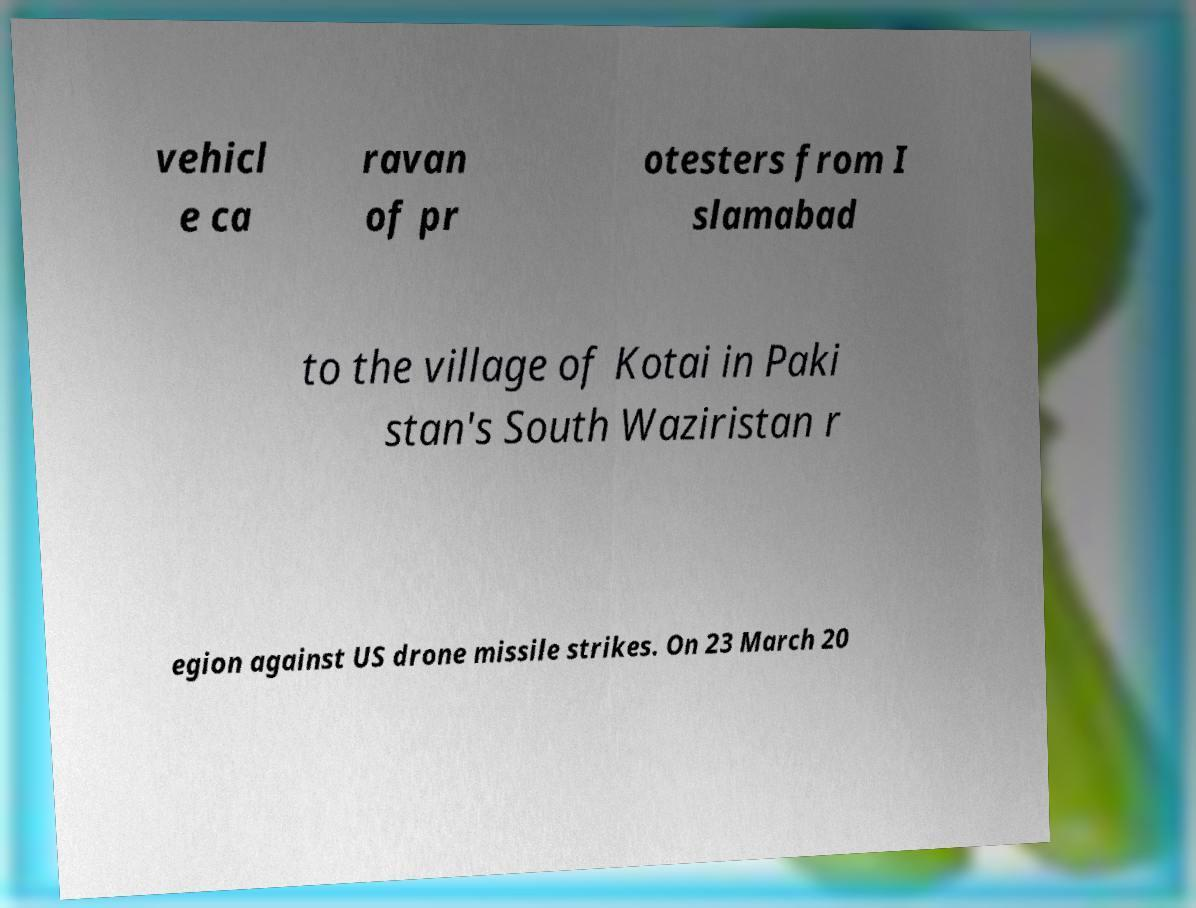For documentation purposes, I need the text within this image transcribed. Could you provide that? vehicl e ca ravan of pr otesters from I slamabad to the village of Kotai in Paki stan's South Waziristan r egion against US drone missile strikes. On 23 March 20 